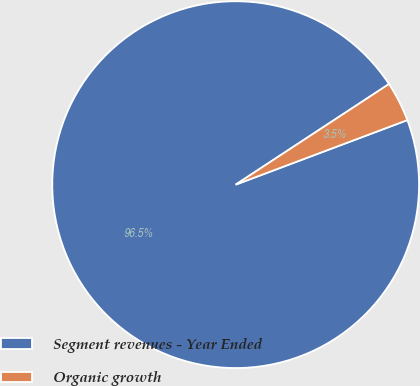Convert chart. <chart><loc_0><loc_0><loc_500><loc_500><pie_chart><fcel>Segment revenues - Year Ended<fcel>Organic growth<nl><fcel>96.48%<fcel>3.52%<nl></chart> 